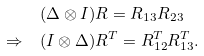Convert formula to latex. <formula><loc_0><loc_0><loc_500><loc_500>& ( \Delta \otimes I ) R = R _ { 1 3 } R _ { 2 3 } \\ \Rightarrow \quad & ( I \otimes \Delta ) R ^ { T } = R ^ { T } _ { 1 2 } R ^ { T } _ { 1 3 } .</formula> 